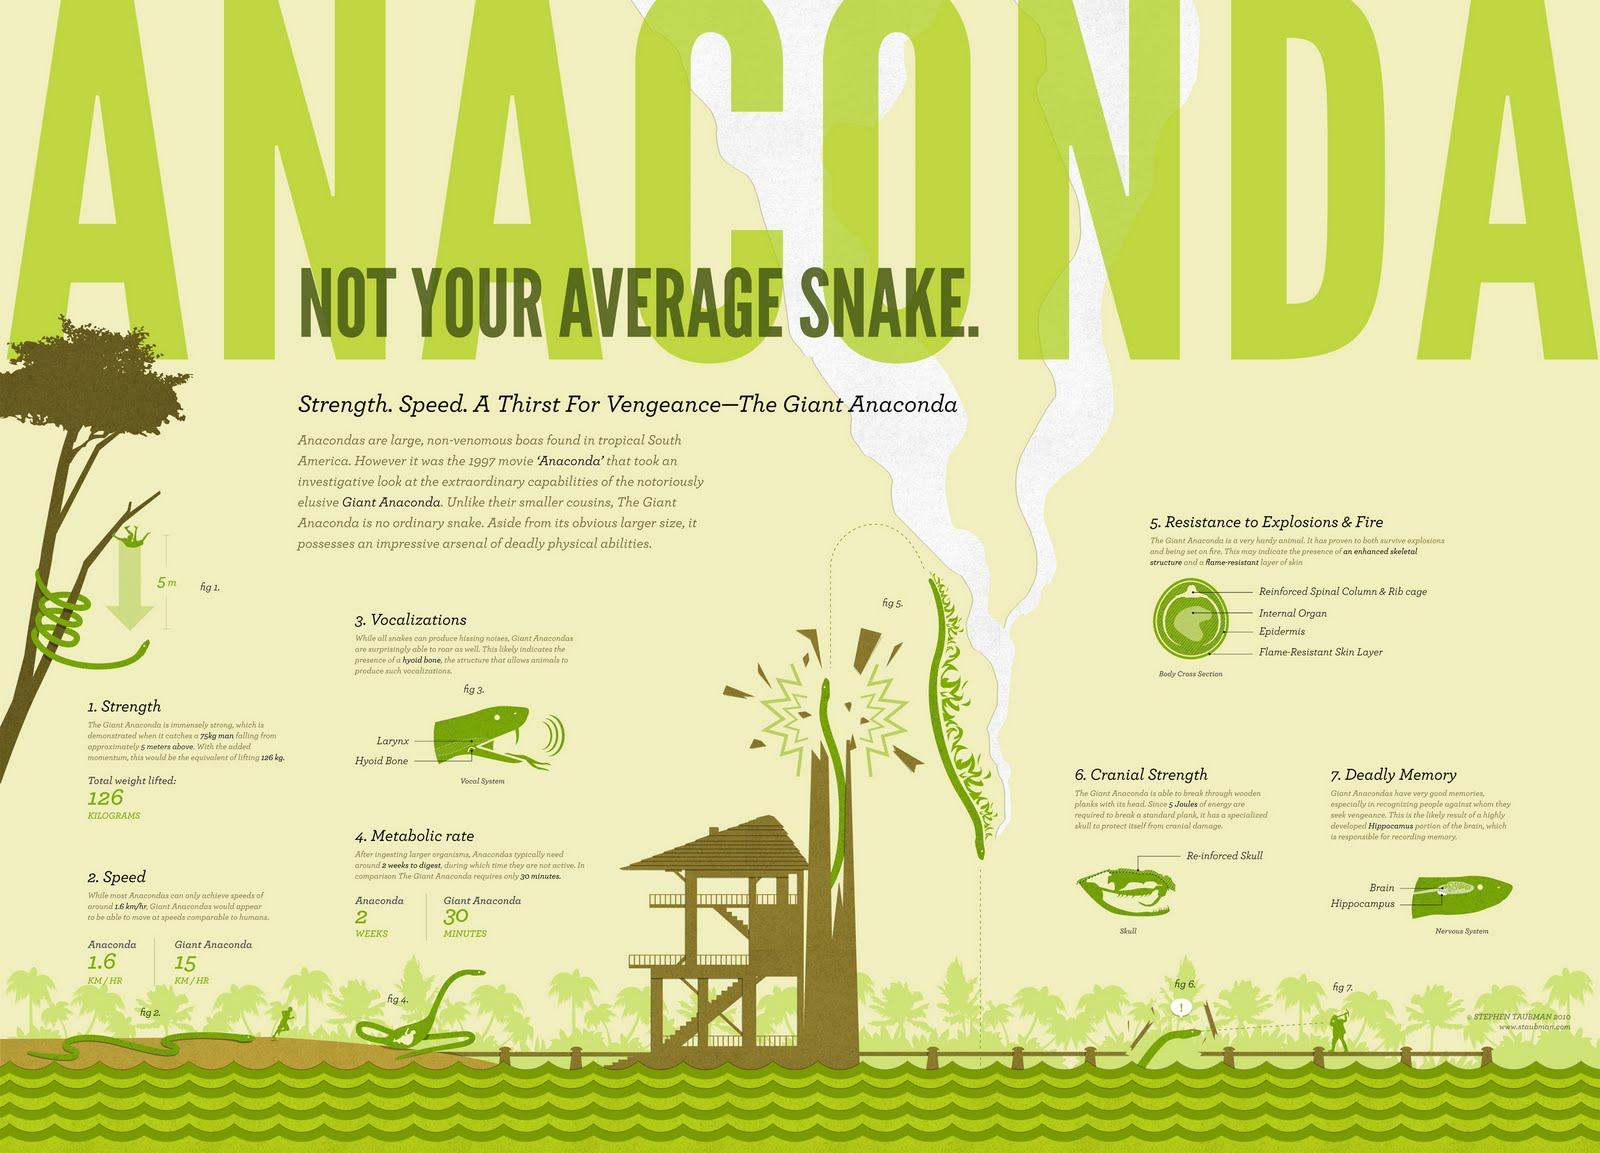Give some essential details in this illustration. In giant anacondas, the hippocampus is responsible for recognizing people. The metabolic rate of giant anacondas is approximately 30 minutes. The total weight lifted by a giant anaconda is 126 kilograms. Anacondas are primarily located in the tropical regions of South America. The structure in giant anacondas that helps to produce a roaring sound is the hyoid bone. 